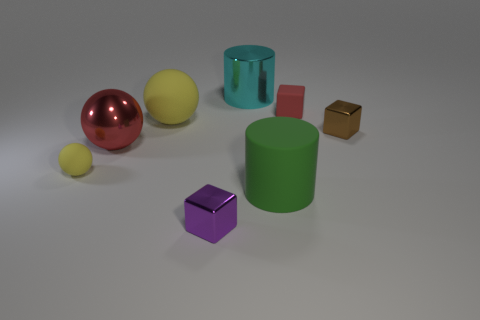Subtract all small metal cubes. How many cubes are left? 1 Subtract all red balls. How many balls are left? 2 Subtract all cubes. How many objects are left? 5 Add 1 tiny purple objects. How many tiny purple objects are left? 2 Add 7 small shiny things. How many small shiny things exist? 9 Add 2 yellow matte spheres. How many objects exist? 10 Subtract 1 purple cubes. How many objects are left? 7 Subtract 2 blocks. How many blocks are left? 1 Subtract all green spheres. Subtract all purple cylinders. How many spheres are left? 3 Subtract all gray cylinders. How many blue blocks are left? 0 